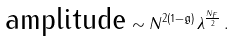<formula> <loc_0><loc_0><loc_500><loc_500>\text {amplitude} \sim N ^ { 2 ( 1 - \mathfrak { g } ) } \lambda ^ { \frac { N _ { F } } { 2 } } \, .</formula> 